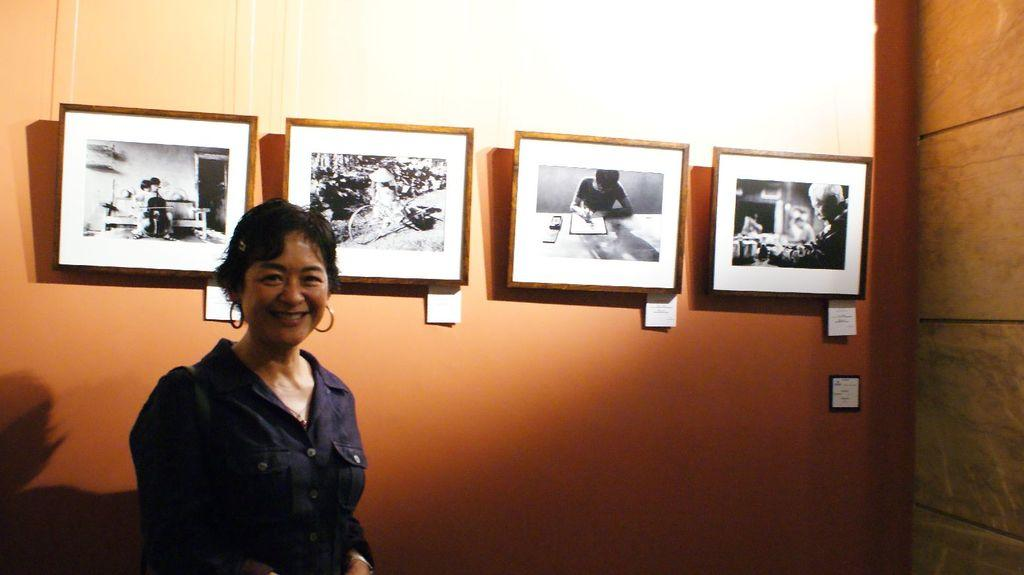What is the primary subject in the image? There is a woman standing in the image. What is the woman's facial expression? The woman is smiling. What can be seen behind the woman? There is a wall behind the woman. What is on the wall? There are photo frames on the wall. What color is the wall? The wall is in orange color. What type of lace can be seen on the woman's clothing in the image? There is no lace visible on the woman's clothing in the image. Is there a railway station in the background of the image? There is no railway station or any reference to a railway in the image. 